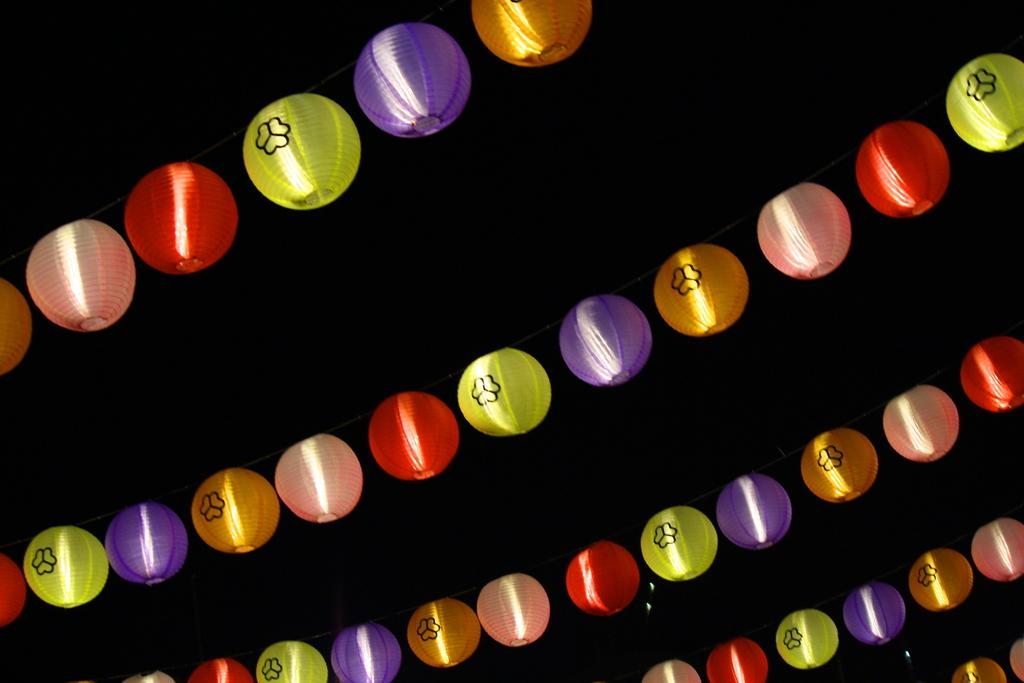What type of lights are in the image? There are ball lights in the image. What distinguishes the ball lights from each other? The ball lights have different colors. How are the ball lights suspended in the image? The ball lights are hanging on ropes. How does the lift help in measuring the grade of the ball lights in the image? There is no lift, measurement, or grade mentioned in the image. The image only features ball lights hanging on ropes with different colors. 